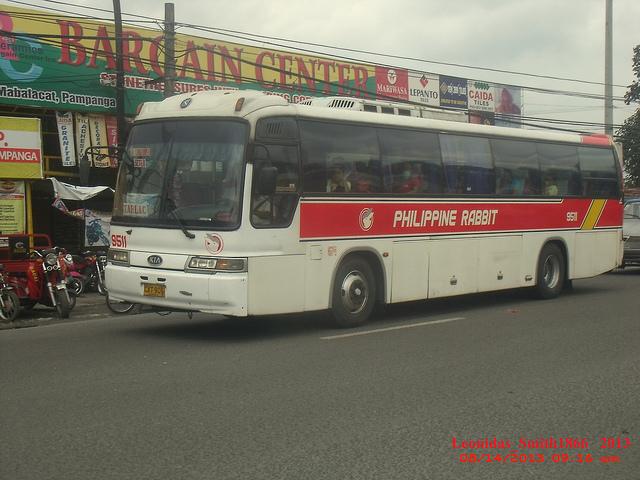What is the bus company?
Quick response, please. Philippine rabbit. Is it likely the bus's detailing is meant to evoke a feeling of carefree fun?
Quick response, please. No. Are there people in the bus?
Concise answer only. Yes. Where did the bus drive by?
Answer briefly. Bargain center. 